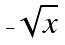Convert formula to latex. <formula><loc_0><loc_0><loc_500><loc_500>- \sqrt { x }</formula> 